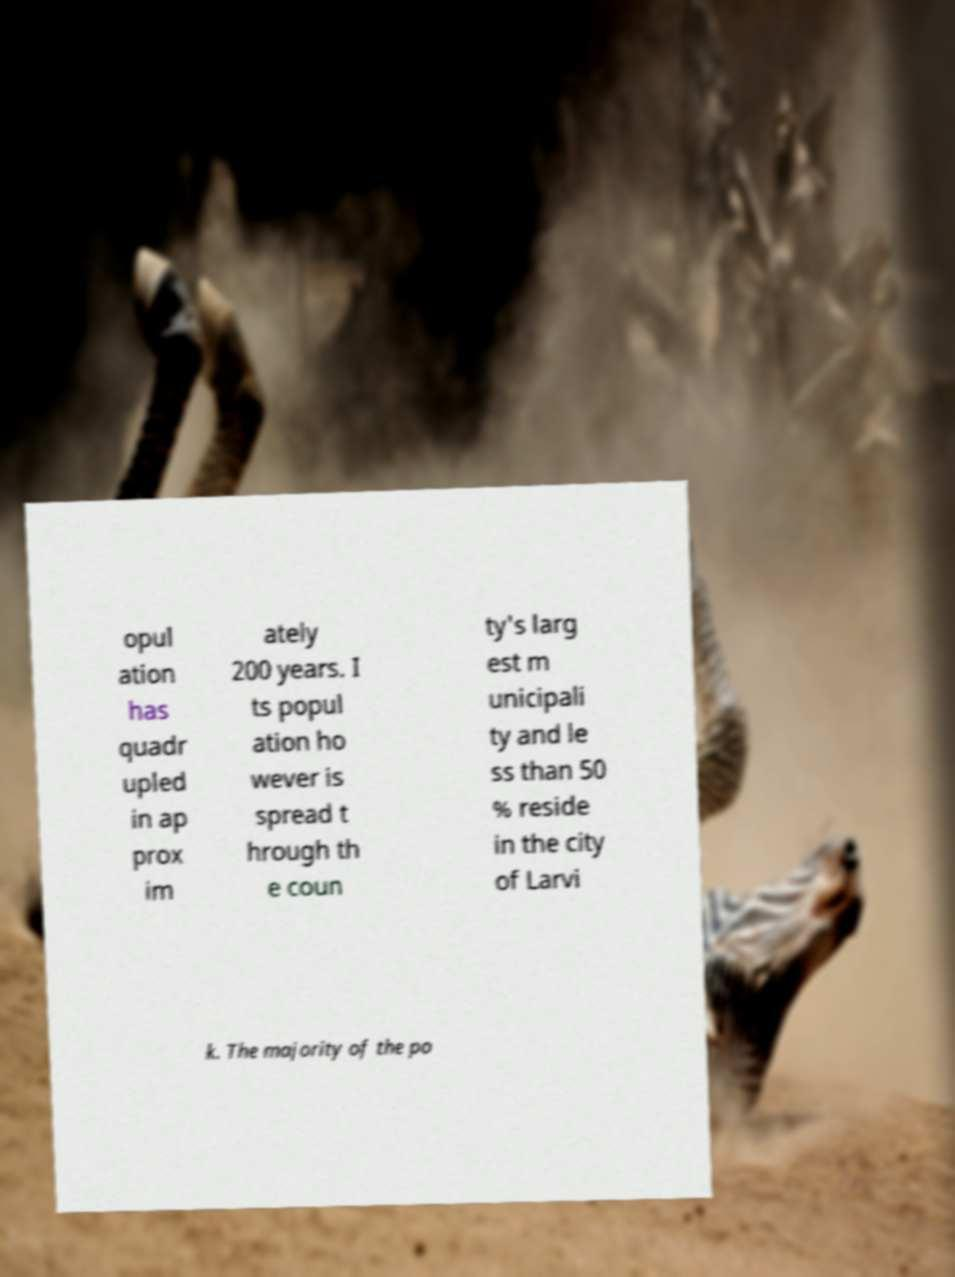I need the written content from this picture converted into text. Can you do that? opul ation has quadr upled in ap prox im ately 200 years. I ts popul ation ho wever is spread t hrough th e coun ty's larg est m unicipali ty and le ss than 50 % reside in the city of Larvi k. The majority of the po 